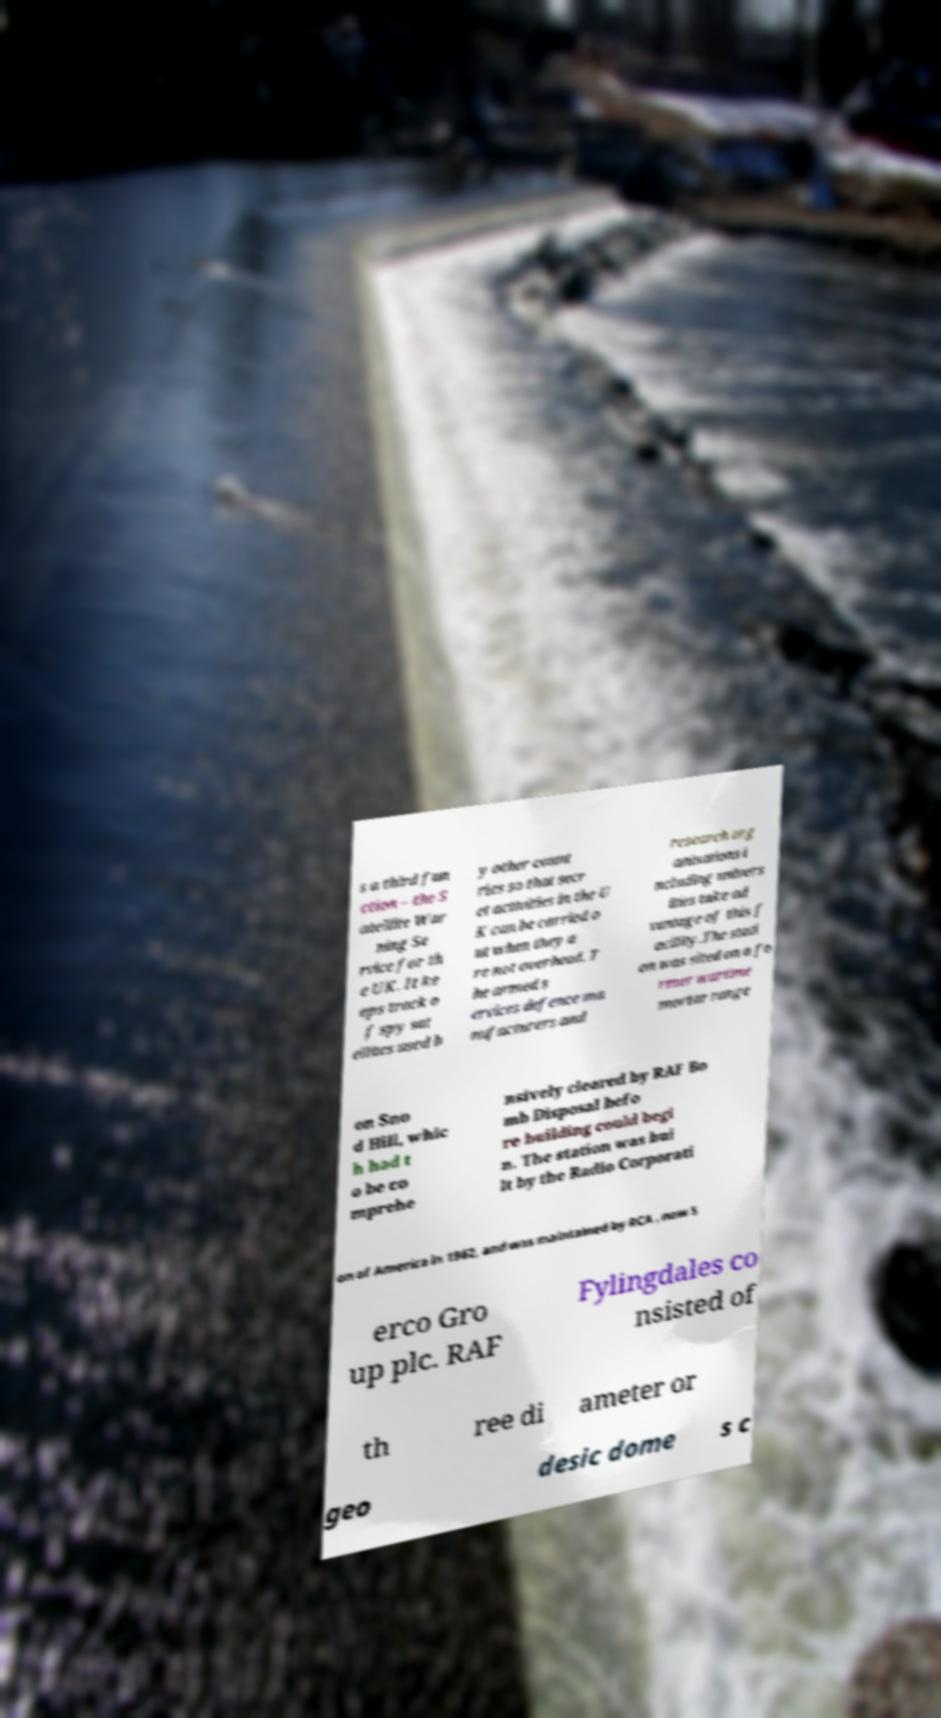Please identify and transcribe the text found in this image. s a third fun ction – the S atellite War ning Se rvice for th e UK. It ke eps track o f spy sat ellites used b y other count ries so that secr et activities in the U K can be carried o ut when they a re not overhead. T he armed s ervices defence ma nufacturers and research org anisations i ncluding univers ities take ad vantage of this f acility.The stati on was sited on a fo rmer wartime mortar range on Sno d Hill, whic h had t o be co mprehe nsively cleared by RAF Bo mb Disposal befo re building could begi n. The station was bui lt by the Radio Corporati on of America in 1962, and was maintained by RCA , now S erco Gro up plc. RAF Fylingdales co nsisted of th ree di ameter or geo desic dome s c 